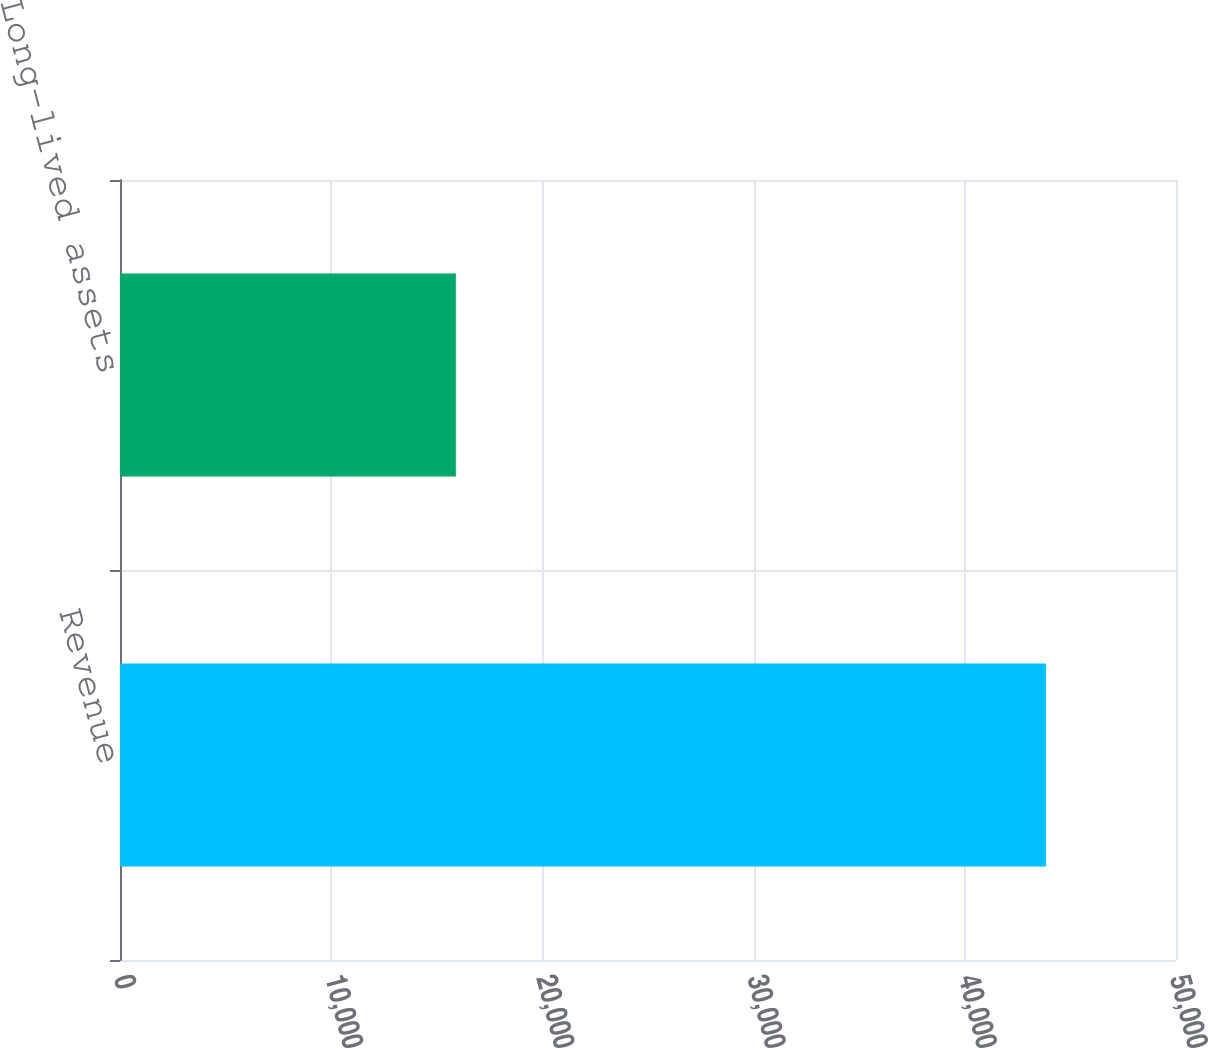<chart> <loc_0><loc_0><loc_500><loc_500><bar_chart><fcel>Revenue<fcel>Long-lived assets<nl><fcel>43840<fcel>15902<nl></chart> 